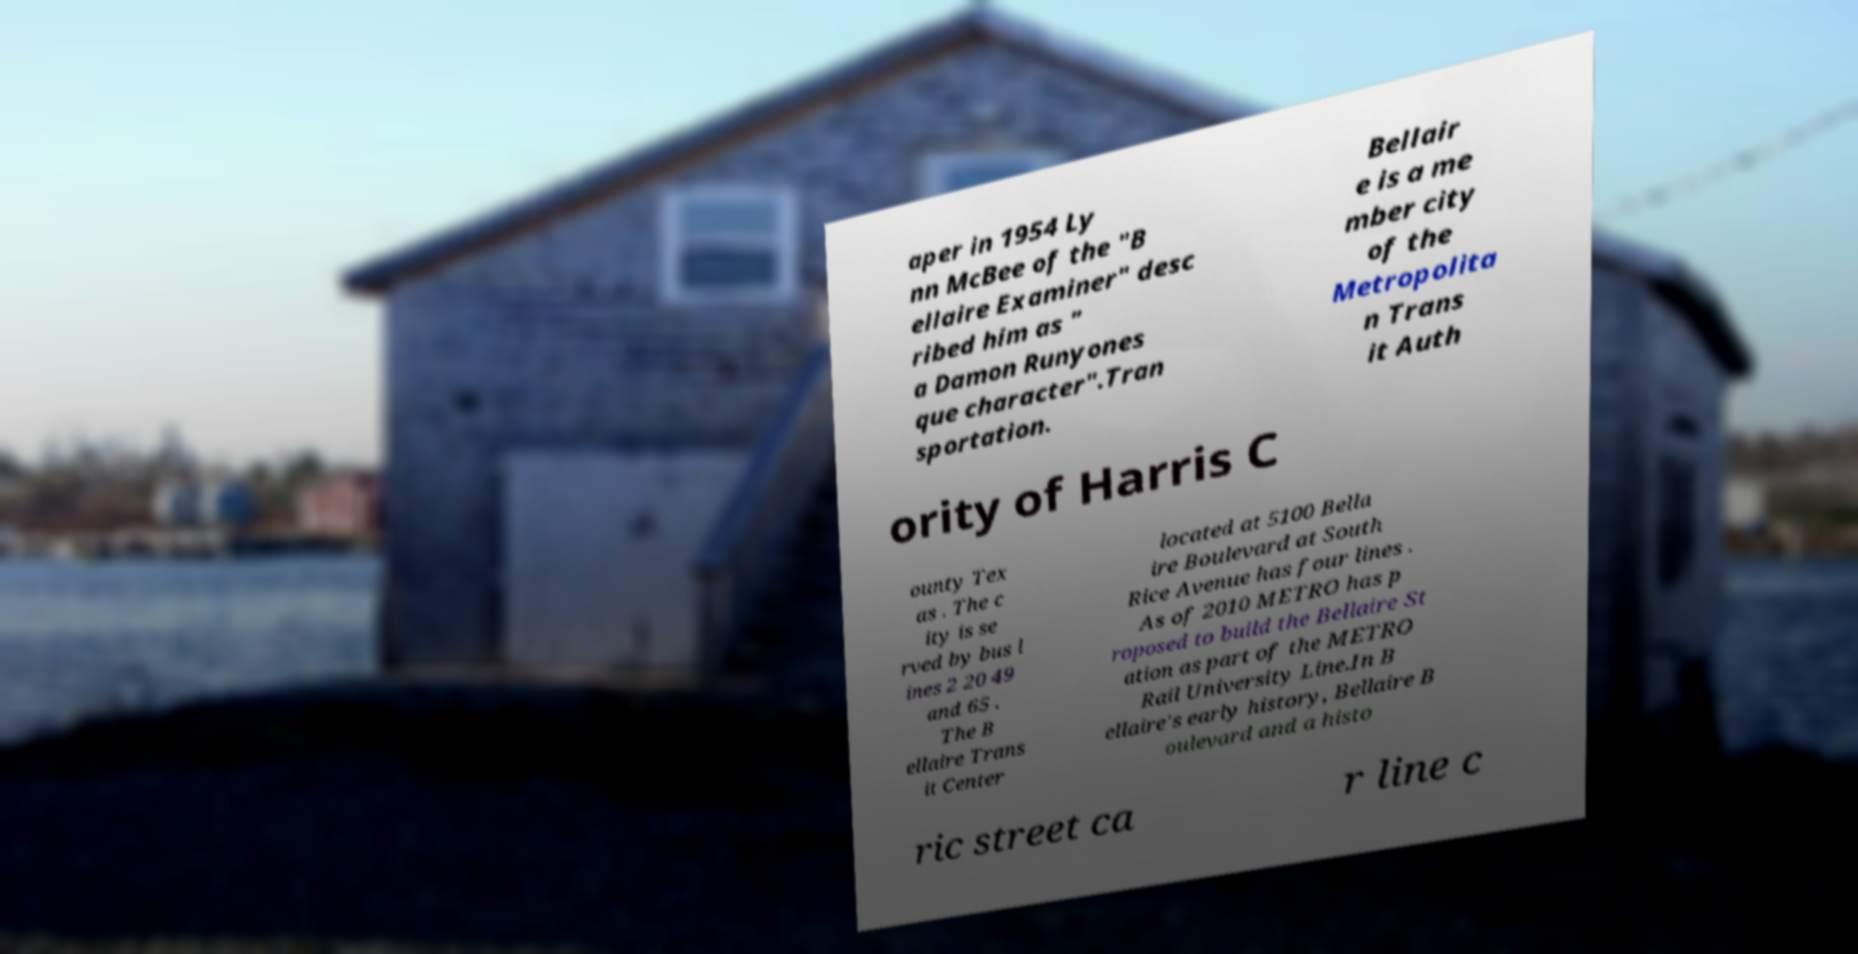I need the written content from this picture converted into text. Can you do that? aper in 1954 Ly nn McBee of the "B ellaire Examiner" desc ribed him as " a Damon Runyones que character".Tran sportation. Bellair e is a me mber city of the Metropolita n Trans it Auth ority of Harris C ounty Tex as . The c ity is se rved by bus l ines 2 20 49 and 65 . The B ellaire Trans it Center located at 5100 Bella ire Boulevard at South Rice Avenue has four lines . As of 2010 METRO has p roposed to build the Bellaire St ation as part of the METRO Rail University Line.In B ellaire's early history, Bellaire B oulevard and a histo ric street ca r line c 